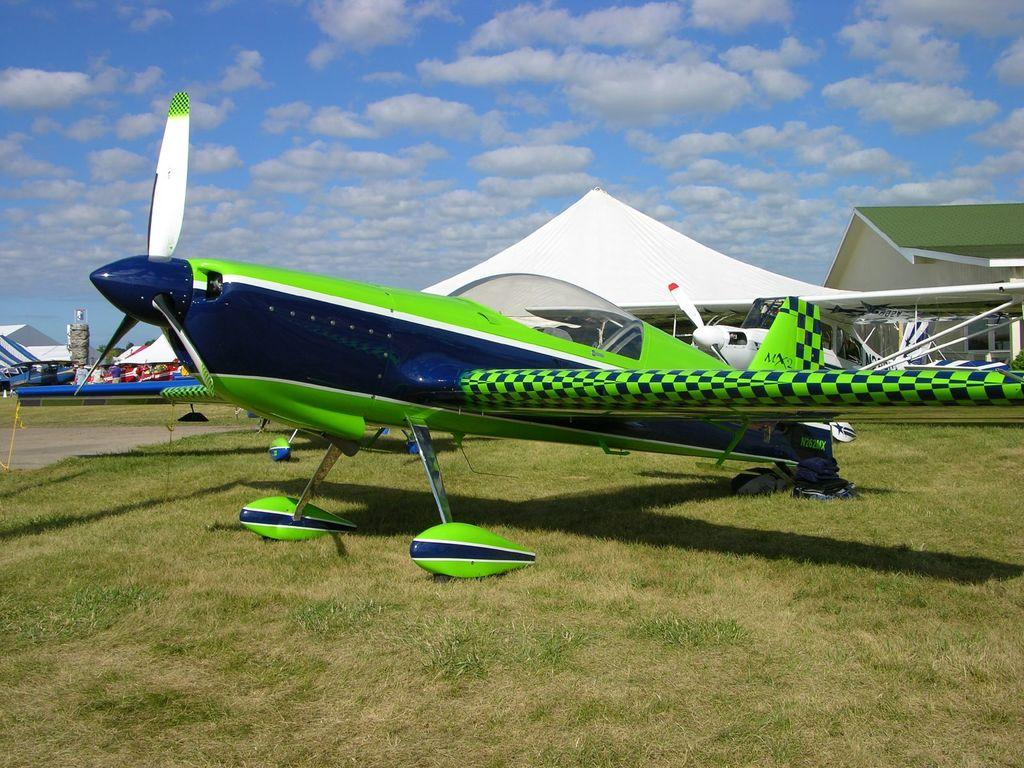What is the main subject of the image? The main subject of the image is an aeroplane. Where is the aeroplane located in the image? The aeroplane is on the ground in the image. What can be seen in the background of the image? In the background of the image, there are sheds, towers, and the sky. What is the condition of the sky in the image? The sky is visible in the background of the image, and clouds are present. What type of spoon is being used to tell a story in the image? There is no spoon or storytelling activity present in the image. What type of railway is visible in the image? There is no railway visible in the image; it features an aeroplane on the ground with sheds, towers, and the sky in the background. 